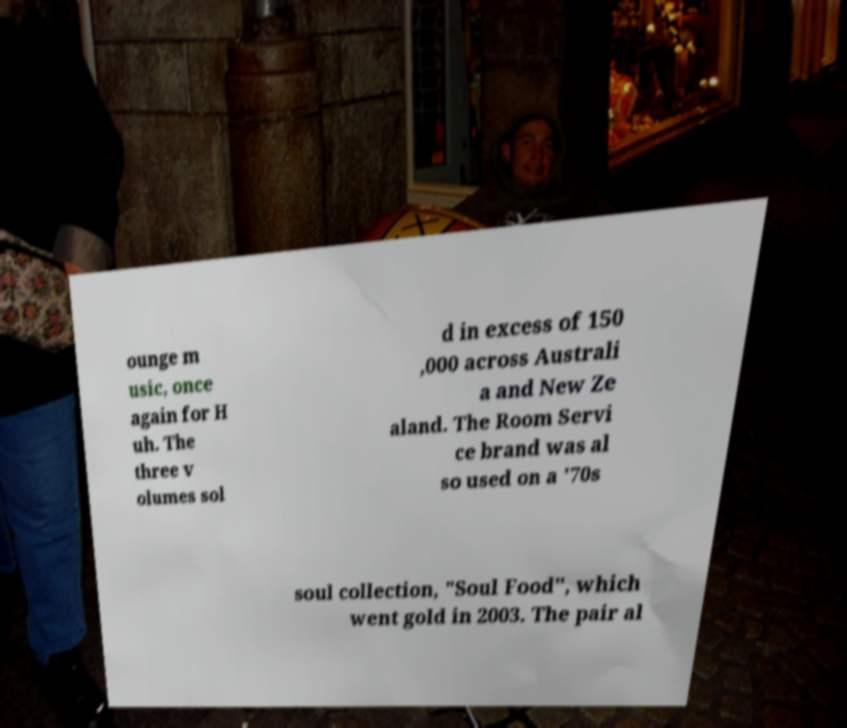There's text embedded in this image that I need extracted. Can you transcribe it verbatim? ounge m usic, once again for H uh. The three v olumes sol d in excess of 150 ,000 across Australi a and New Ze aland. The Room Servi ce brand was al so used on a '70s soul collection, "Soul Food", which went gold in 2003. The pair al 